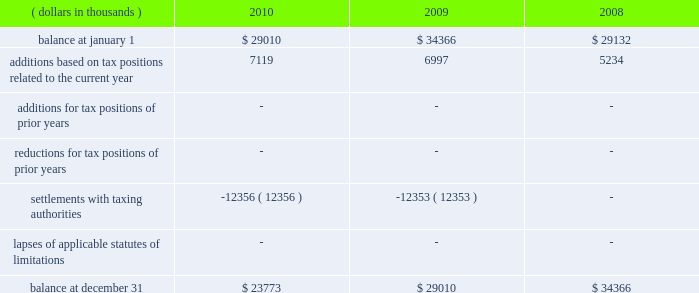A reconciliation of the beginning and ending amount of unrecognized tax benefits , for the periods indicated , is as follows: .
The entire amount of the unrecognized tax benefits would affect the effective tax rate if recognized .
In 2010 , the company favorably settled a 2003 and 2004 irs audit .
The company recorded a net overall tax benefit including accrued interest of $ 25920 thousand .
In addition , the company was also able to take down a $ 12356 thousand fin 48 reserve that had been established regarding the 2003 and 2004 irs audit .
The company is no longer subject to u.s .
Federal , state and local or foreign income tax examinations by tax authorities for years before 2007 .
The company recognizes accrued interest related to net unrecognized tax benefits and penalties in income taxes .
During the years ended december 31 , 2010 , 2009 and 2008 , the company accrued and recognized a net expense ( benefit ) of approximately $ ( 9938 ) thousand , $ 1563 thousand and $ 2446 thousand , respectively , in interest and penalties .
Included within the 2010 net expense ( benefit ) of $ ( 9938 ) thousand is $ ( 10591 ) thousand of accrued interest related to the 2003 and 2004 irs audit .
The company is not aware of any positions for which it is reasonably possible that the total amounts of unrecognized tax benefits will significantly increase or decrease within twelve months of the reporting date .
For u.s .
Income tax purposes the company has foreign tax credit carryforwards of $ 55026 thousand that begin to expire in 2014 .
In addition , for u.s .
Income tax purposes the company has $ 41693 thousand of alternative minimum tax credits that do not expire .
Management believes that it is more likely than not that the company will realize the benefits of its net deferred tax assets and , accordingly , no valuation allowance has been recorded for the periods presented .
Tax benefits of $ 629 thousand and $ 1714 thousand related to share-based compensation deductions for stock options exercised in 2010 and 2009 , respectively , are included within additional paid-in capital of the shareholders 2019 equity section of the consolidated balance sheets. .
In 2010 what was the percentage change in the unrecognized tax benefits,? 
Computations: ((23773 - 29010) / 29010)
Answer: -0.18052. 